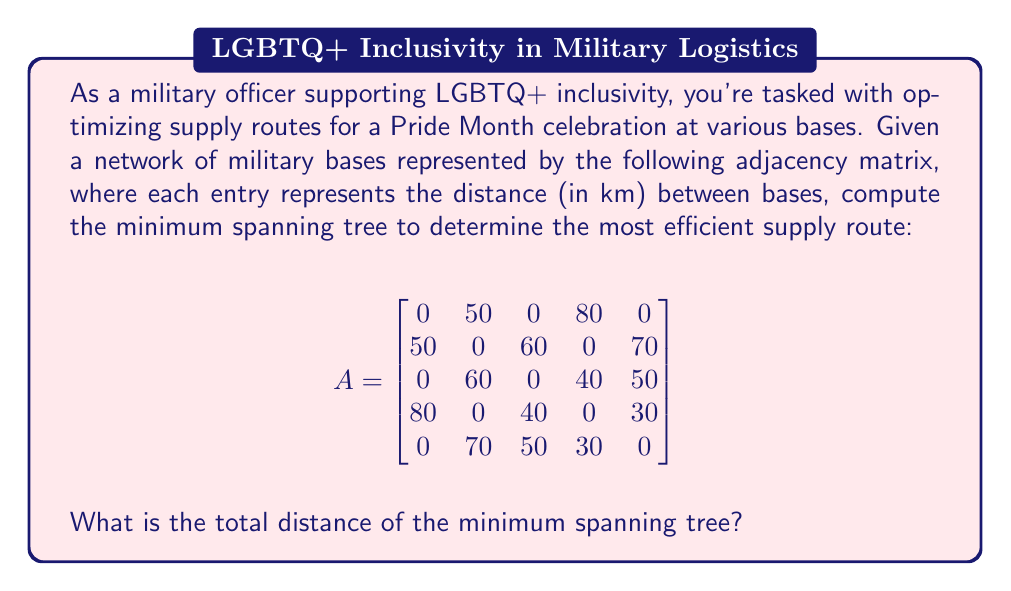Show me your answer to this math problem. To solve this problem, we'll use Kruskal's algorithm to find the minimum spanning tree (MST) of the graph represented by the adjacency matrix. This algorithm is efficient for determining the most cost-effective way to connect all nodes in a weighted, undirected graph.

Steps:
1. List all edges and their weights:
   (1,2): 50km, (1,4): 80km, (2,3): 60km, (2,5): 70km, (3,4): 40km, (3,5): 50km, (4,5): 30km

2. Sort edges by weight in ascending order:
   (4,5): 30km, (3,4): 40km, (1,2): 50km, (3,5): 50km, (2,3): 60km, (2,5): 70km, (1,4): 80km

3. Apply Kruskal's algorithm:
   a) Add (4,5): 30km (connects bases 4 and 5)
   b) Add (3,4): 40km (connects base 3 to the existing component)
   c) Add (1,2): 50km (connects bases 1 and 2)
   d) Add (2,3): 60km (connects the two components, completing the MST)

The MST now includes all 5 bases with 4 edges.

4. Sum the weights of the edges in the MST:
   30 + 40 + 50 + 60 = 180km

Therefore, the total distance of the minimum spanning tree is 180km.

[asy]
unitsize(4cm);
pair A=(0,0), B=(1,0), C=(0.5,0.866), D=(0.5,-0.866), E=(-0.5,-0.866);
draw(A--B--C--D--E,blue);
draw(C--D,blue);
label("1",A,W);
label("2",B,E);
label("3",C,N);
label("4",D,SE);
label("5",E,SW);
label("50",A--B,N);
label("60",B--C,NE);
label("40",C--D,E);
label("30",D--E,S);
[/asy]
Answer: 180 km 